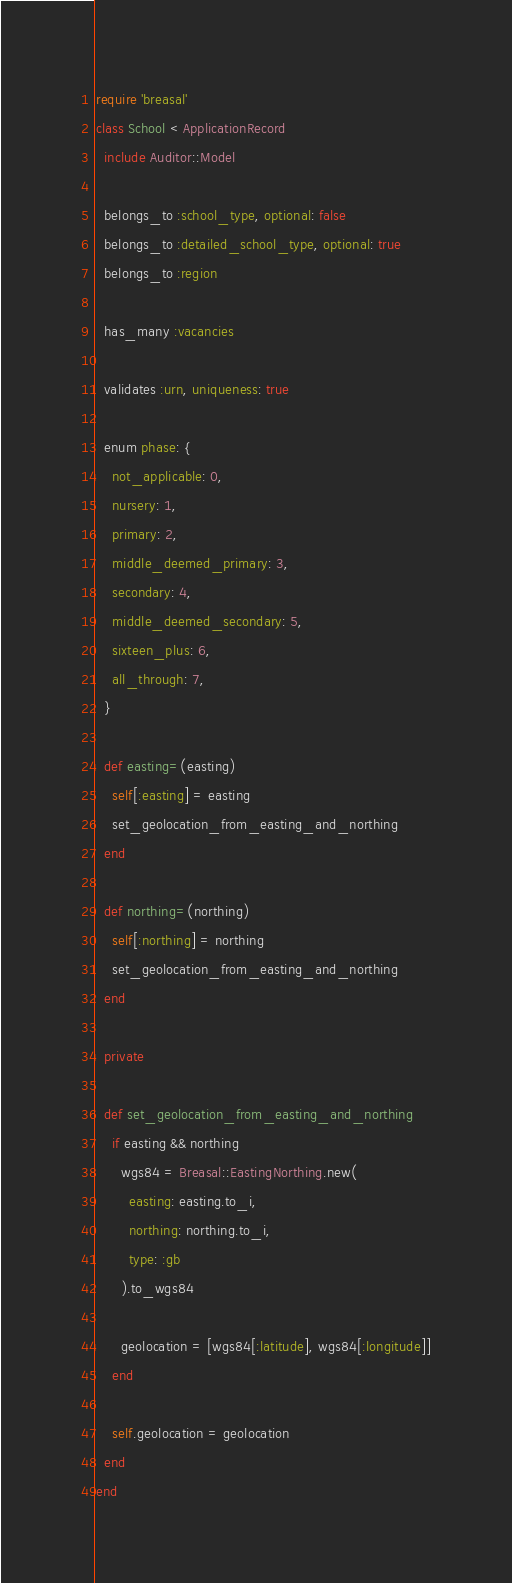Convert code to text. <code><loc_0><loc_0><loc_500><loc_500><_Ruby_>require 'breasal'
class School < ApplicationRecord
  include Auditor::Model

  belongs_to :school_type, optional: false
  belongs_to :detailed_school_type, optional: true
  belongs_to :region

  has_many :vacancies

  validates :urn, uniqueness: true

  enum phase: {
    not_applicable: 0,
    nursery: 1,
    primary: 2,
    middle_deemed_primary: 3,
    secondary: 4,
    middle_deemed_secondary: 5,
    sixteen_plus: 6,
    all_through: 7,
  }

  def easting=(easting)
    self[:easting] = easting
    set_geolocation_from_easting_and_northing
  end

  def northing=(northing)
    self[:northing] = northing
    set_geolocation_from_easting_and_northing
  end

  private

  def set_geolocation_from_easting_and_northing
    if easting && northing
      wgs84 = Breasal::EastingNorthing.new(
        easting: easting.to_i,
        northing: northing.to_i,
        type: :gb
      ).to_wgs84

      geolocation = [wgs84[:latitude], wgs84[:longitude]]
    end

    self.geolocation = geolocation
  end
end
</code> 